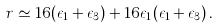Convert formula to latex. <formula><loc_0><loc_0><loc_500><loc_500>r \simeq 1 6 ( \epsilon _ { 1 } + \epsilon _ { 3 } ) + 1 6 \epsilon _ { 1 } ( \epsilon _ { 1 } + \epsilon _ { 3 } ) \, .</formula> 